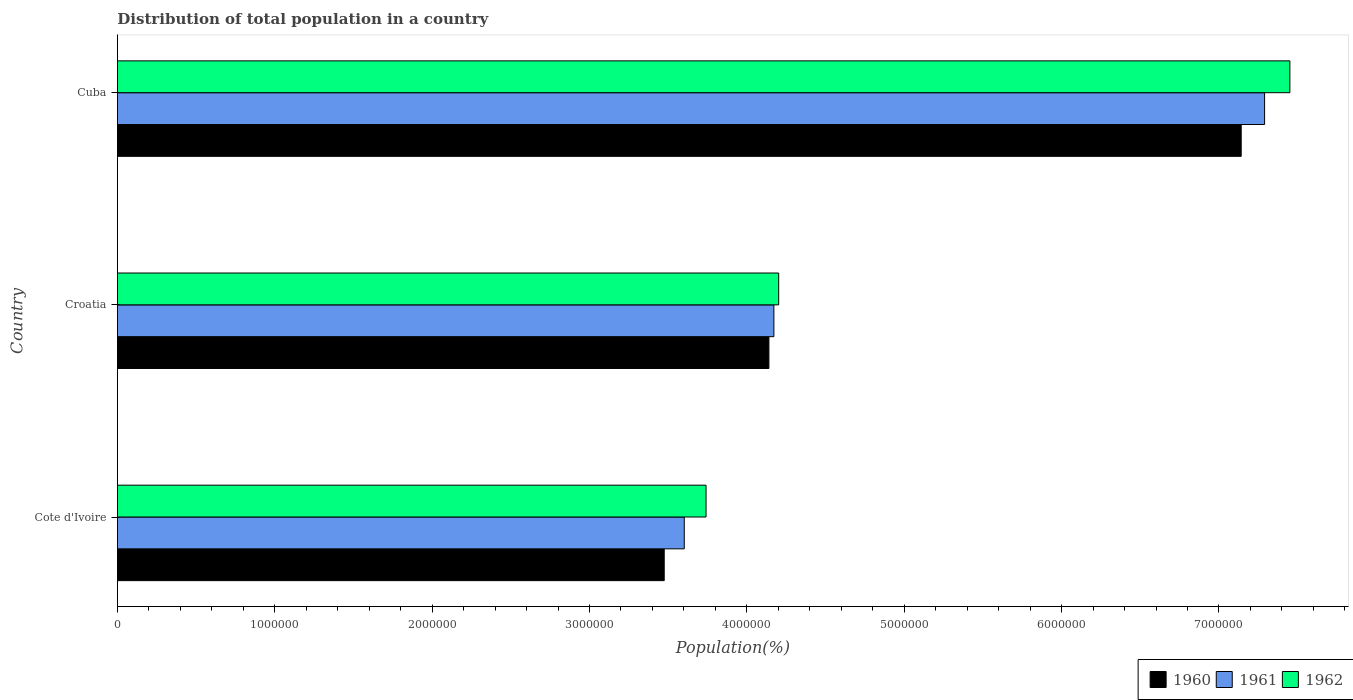What is the label of the 1st group of bars from the top?
Your answer should be compact. Cuba. In how many cases, is the number of bars for a given country not equal to the number of legend labels?
Provide a succinct answer. 0. What is the population of in 1960 in Croatia?
Your answer should be very brief. 4.14e+06. Across all countries, what is the maximum population of in 1961?
Offer a terse response. 7.29e+06. Across all countries, what is the minimum population of in 1962?
Your response must be concise. 3.74e+06. In which country was the population of in 1962 maximum?
Your response must be concise. Cuba. In which country was the population of in 1961 minimum?
Offer a terse response. Cote d'Ivoire. What is the total population of in 1961 in the graph?
Keep it short and to the point. 1.51e+07. What is the difference between the population of in 1961 in Cote d'Ivoire and that in Cuba?
Offer a terse response. -3.69e+06. What is the difference between the population of in 1962 in Croatia and the population of in 1961 in Cote d'Ivoire?
Your answer should be very brief. 6.00e+05. What is the average population of in 1960 per country?
Offer a very short reply. 4.92e+06. What is the difference between the population of in 1962 and population of in 1961 in Cote d'Ivoire?
Ensure brevity in your answer.  1.38e+05. What is the ratio of the population of in 1962 in Croatia to that in Cuba?
Ensure brevity in your answer.  0.56. Is the population of in 1962 in Croatia less than that in Cuba?
Provide a succinct answer. Yes. What is the difference between the highest and the second highest population of in 1962?
Provide a succinct answer. 3.25e+06. What is the difference between the highest and the lowest population of in 1960?
Give a very brief answer. 3.67e+06. What does the 2nd bar from the top in Cuba represents?
Make the answer very short. 1961. What does the 3rd bar from the bottom in Croatia represents?
Your answer should be very brief. 1962. How many bars are there?
Give a very brief answer. 9. Are all the bars in the graph horizontal?
Your response must be concise. Yes. Are the values on the major ticks of X-axis written in scientific E-notation?
Your answer should be very brief. No. Does the graph contain grids?
Your answer should be compact. No. Where does the legend appear in the graph?
Offer a very short reply. Bottom right. How many legend labels are there?
Your answer should be compact. 3. What is the title of the graph?
Provide a succinct answer. Distribution of total population in a country. Does "1993" appear as one of the legend labels in the graph?
Offer a terse response. No. What is the label or title of the X-axis?
Your answer should be compact. Population(%). What is the label or title of the Y-axis?
Your answer should be compact. Country. What is the Population(%) of 1960 in Cote d'Ivoire?
Give a very brief answer. 3.47e+06. What is the Population(%) of 1961 in Cote d'Ivoire?
Offer a terse response. 3.60e+06. What is the Population(%) in 1962 in Cote d'Ivoire?
Offer a terse response. 3.74e+06. What is the Population(%) in 1960 in Croatia?
Provide a succinct answer. 4.14e+06. What is the Population(%) of 1961 in Croatia?
Make the answer very short. 4.17e+06. What is the Population(%) of 1962 in Croatia?
Provide a short and direct response. 4.20e+06. What is the Population(%) in 1960 in Cuba?
Your answer should be very brief. 7.14e+06. What is the Population(%) in 1961 in Cuba?
Give a very brief answer. 7.29e+06. What is the Population(%) in 1962 in Cuba?
Keep it short and to the point. 7.45e+06. Across all countries, what is the maximum Population(%) in 1960?
Offer a very short reply. 7.14e+06. Across all countries, what is the maximum Population(%) in 1961?
Your response must be concise. 7.29e+06. Across all countries, what is the maximum Population(%) of 1962?
Give a very brief answer. 7.45e+06. Across all countries, what is the minimum Population(%) of 1960?
Keep it short and to the point. 3.47e+06. Across all countries, what is the minimum Population(%) of 1961?
Offer a very short reply. 3.60e+06. Across all countries, what is the minimum Population(%) of 1962?
Provide a succinct answer. 3.74e+06. What is the total Population(%) in 1960 in the graph?
Provide a succinct answer. 1.48e+07. What is the total Population(%) in 1961 in the graph?
Make the answer very short. 1.51e+07. What is the total Population(%) of 1962 in the graph?
Make the answer very short. 1.54e+07. What is the difference between the Population(%) in 1960 in Cote d'Ivoire and that in Croatia?
Give a very brief answer. -6.65e+05. What is the difference between the Population(%) in 1961 in Cote d'Ivoire and that in Croatia?
Offer a very short reply. -5.70e+05. What is the difference between the Population(%) of 1962 in Cote d'Ivoire and that in Croatia?
Your response must be concise. -4.62e+05. What is the difference between the Population(%) in 1960 in Cote d'Ivoire and that in Cuba?
Offer a very short reply. -3.67e+06. What is the difference between the Population(%) of 1961 in Cote d'Ivoire and that in Cuba?
Make the answer very short. -3.69e+06. What is the difference between the Population(%) of 1962 in Cote d'Ivoire and that in Cuba?
Offer a very short reply. -3.71e+06. What is the difference between the Population(%) of 1960 in Croatia and that in Cuba?
Offer a terse response. -3.00e+06. What is the difference between the Population(%) of 1961 in Croatia and that in Cuba?
Give a very brief answer. -3.12e+06. What is the difference between the Population(%) in 1962 in Croatia and that in Cuba?
Make the answer very short. -3.25e+06. What is the difference between the Population(%) of 1960 in Cote d'Ivoire and the Population(%) of 1961 in Croatia?
Your response must be concise. -6.97e+05. What is the difference between the Population(%) of 1960 in Cote d'Ivoire and the Population(%) of 1962 in Croatia?
Provide a succinct answer. -7.27e+05. What is the difference between the Population(%) in 1961 in Cote d'Ivoire and the Population(%) in 1962 in Croatia?
Make the answer very short. -6.00e+05. What is the difference between the Population(%) of 1960 in Cote d'Ivoire and the Population(%) of 1961 in Cuba?
Provide a short and direct response. -3.82e+06. What is the difference between the Population(%) of 1960 in Cote d'Ivoire and the Population(%) of 1962 in Cuba?
Your response must be concise. -3.98e+06. What is the difference between the Population(%) of 1961 in Cote d'Ivoire and the Population(%) of 1962 in Cuba?
Ensure brevity in your answer.  -3.85e+06. What is the difference between the Population(%) in 1960 in Croatia and the Population(%) in 1961 in Cuba?
Make the answer very short. -3.15e+06. What is the difference between the Population(%) in 1960 in Croatia and the Population(%) in 1962 in Cuba?
Your answer should be compact. -3.31e+06. What is the difference between the Population(%) in 1961 in Croatia and the Population(%) in 1962 in Cuba?
Your answer should be compact. -3.28e+06. What is the average Population(%) in 1960 per country?
Ensure brevity in your answer.  4.92e+06. What is the average Population(%) in 1961 per country?
Give a very brief answer. 5.02e+06. What is the average Population(%) of 1962 per country?
Your answer should be compact. 5.13e+06. What is the difference between the Population(%) in 1960 and Population(%) in 1961 in Cote d'Ivoire?
Ensure brevity in your answer.  -1.27e+05. What is the difference between the Population(%) in 1960 and Population(%) in 1962 in Cote d'Ivoire?
Your answer should be very brief. -2.66e+05. What is the difference between the Population(%) in 1961 and Population(%) in 1962 in Cote d'Ivoire?
Your answer should be compact. -1.38e+05. What is the difference between the Population(%) in 1960 and Population(%) in 1961 in Croatia?
Provide a succinct answer. -3.17e+04. What is the difference between the Population(%) of 1960 and Population(%) of 1962 in Croatia?
Your answer should be compact. -6.21e+04. What is the difference between the Population(%) in 1961 and Population(%) in 1962 in Croatia?
Keep it short and to the point. -3.04e+04. What is the difference between the Population(%) in 1960 and Population(%) in 1961 in Cuba?
Ensure brevity in your answer.  -1.49e+05. What is the difference between the Population(%) of 1960 and Population(%) of 1962 in Cuba?
Offer a terse response. -3.09e+05. What is the difference between the Population(%) of 1961 and Population(%) of 1962 in Cuba?
Provide a succinct answer. -1.61e+05. What is the ratio of the Population(%) of 1960 in Cote d'Ivoire to that in Croatia?
Offer a terse response. 0.84. What is the ratio of the Population(%) of 1961 in Cote d'Ivoire to that in Croatia?
Your answer should be compact. 0.86. What is the ratio of the Population(%) in 1962 in Cote d'Ivoire to that in Croatia?
Make the answer very short. 0.89. What is the ratio of the Population(%) in 1960 in Cote d'Ivoire to that in Cuba?
Give a very brief answer. 0.49. What is the ratio of the Population(%) of 1961 in Cote d'Ivoire to that in Cuba?
Offer a very short reply. 0.49. What is the ratio of the Population(%) in 1962 in Cote d'Ivoire to that in Cuba?
Offer a terse response. 0.5. What is the ratio of the Population(%) in 1960 in Croatia to that in Cuba?
Your answer should be very brief. 0.58. What is the ratio of the Population(%) in 1961 in Croatia to that in Cuba?
Provide a short and direct response. 0.57. What is the ratio of the Population(%) in 1962 in Croatia to that in Cuba?
Give a very brief answer. 0.56. What is the difference between the highest and the second highest Population(%) of 1960?
Your response must be concise. 3.00e+06. What is the difference between the highest and the second highest Population(%) of 1961?
Make the answer very short. 3.12e+06. What is the difference between the highest and the second highest Population(%) of 1962?
Make the answer very short. 3.25e+06. What is the difference between the highest and the lowest Population(%) of 1960?
Offer a terse response. 3.67e+06. What is the difference between the highest and the lowest Population(%) of 1961?
Provide a succinct answer. 3.69e+06. What is the difference between the highest and the lowest Population(%) in 1962?
Your answer should be compact. 3.71e+06. 